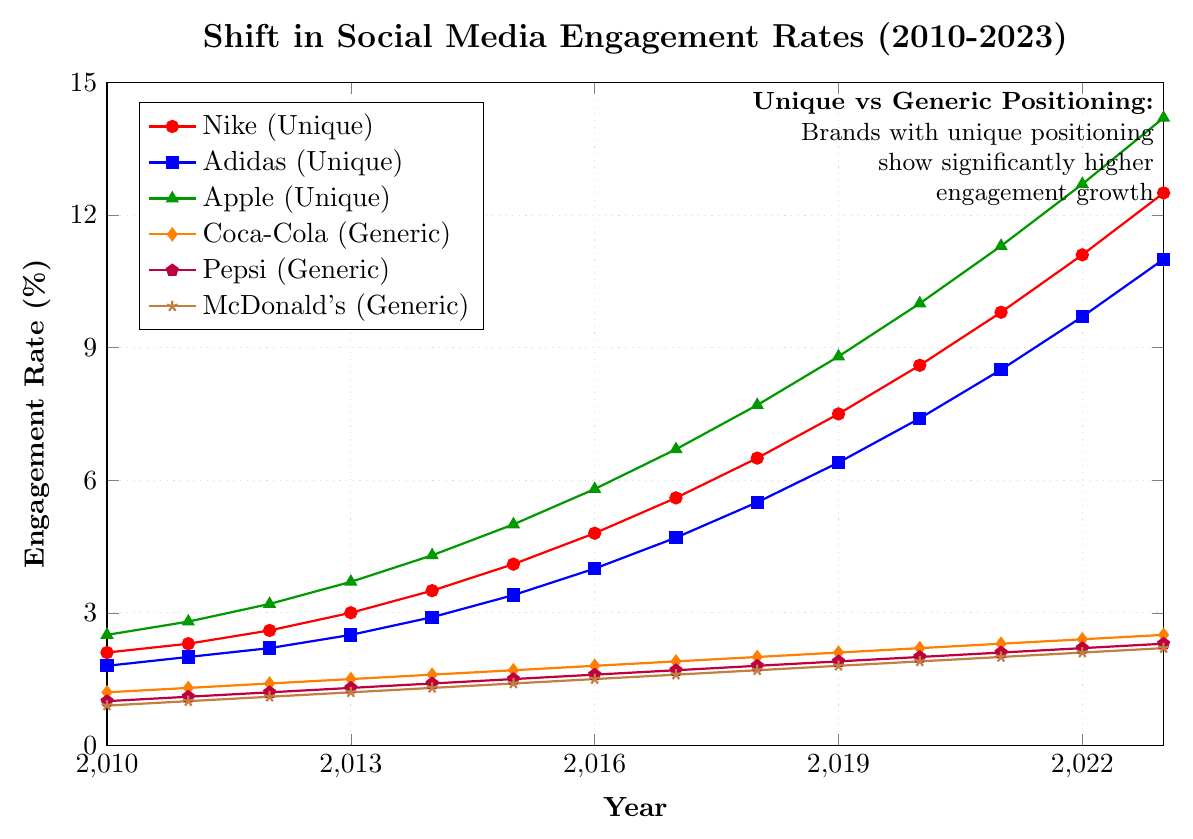What has the engagement rate for Nike (Unique) increased to from 2010 to 2023? The engagement rate for Nike (Unique) in 2010 is 2.1%, and it increases to 12.5% in 2023. The difference is 12.5% - 2.1% = 10.4%.
Answer: 10.4% Which brand had the highest engagement rate in 2023 and what was the value? By observing the highest point in 2023, Apple (Unique) has the highest engagement rate at 14.2%.
Answer: Apple, 14.2% What is the average engagement rate for Coca-Cola (Generic) from 2010 to 2023? Sum the engagement rates for Coca-Cola (Generic) from 2010 to 2023 and divide by the number of years: (1.2 + 1.3 + 1.4 + 1.5 + 1.6 + 1.7 + 1.8 + 1.9 + 2.0 + 2.1 + 2.2 + 2.3 + 2.4 + 2.5) / 14 = 1.8143%.
Answer: 1.8143% Between Adidas (Unique) and Pepsi (Generic), which brand had a faster growth rate from 2010 to 2023 and what is the difference? Calculate the difference for both brands: Adidas (Unique) increases from 1.8% to 11.0%, which is 11.0% - 1.8% = 9.2%. Pepsi (Generic) increases from 1.0% to 2.3%, which is 2.3% - 1.0% = 1.3%. The faster growth is 9.2% - 1.3% = 7.9%.
Answer: Adidas, 7.9% Looking at the colors in the chart, which lines represent brands with unique positioning? Identify the colors of the lines representing unique brands: red, blue, and green. These colors correspond to Nike, Adidas, and Apple respectively.
Answer: Nike, Adidas, Apple How much larger is the engagement rate for Apple (Unique) compared to McDonald's (Generic) in 2023? Subtract McDonald's engagement rate in 2023 from Apple’s engagement rate: 14.2% - 2.2% = 12.0%.
Answer: 12.0% Which year did Nike (Unique) surpass 5% engagement rate? By examining the values, Nike surpassed 5% engagement rate in 2017 when it reached 5.6%.
Answer: 2017 Compare the engagement trend of Adidas (Unique) and McDonald's (Generic) over the period. Which brand showed a steadier increase? Adidas shows a consistent upward trend from 1.8% to 11.0%. McDonald's also shows a steady increase from 0.9% to 2.2%, but at a lower rate. By comparing the slopes, McDonald's increase is steadier though smaller.
Answer: McDonald's 